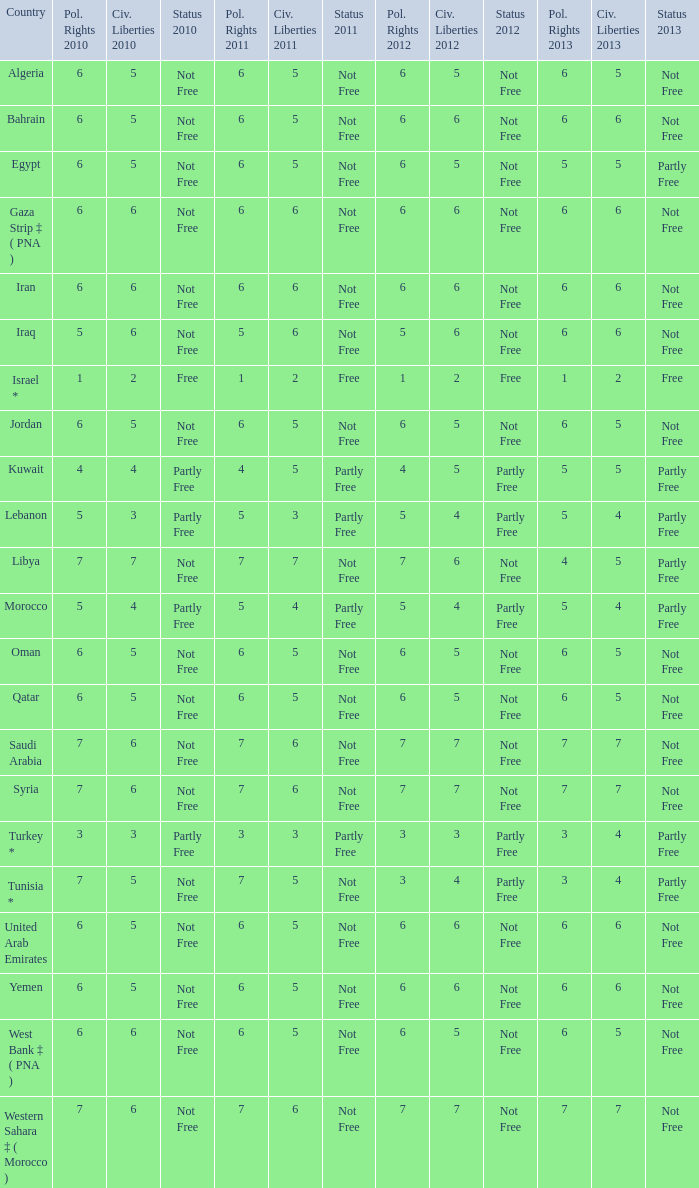What is the total number of civil liberties 2011 values having 2010 political rights values under 3 and 2011 political rights values under 1? 0.0. 